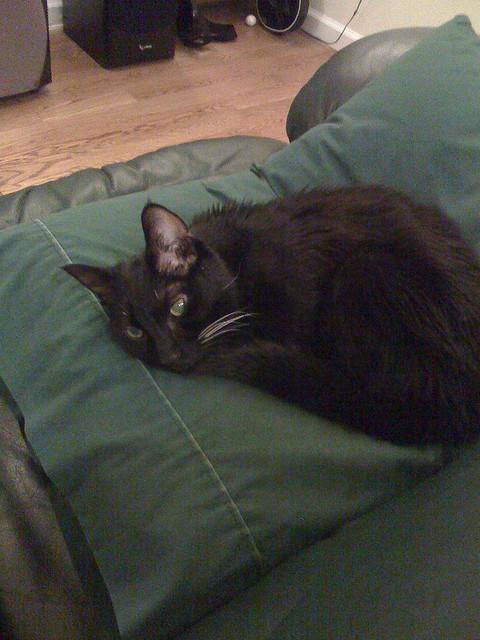Is this cat sleeping?
Answer briefly. No. Does this cat sometimes go outside?
Write a very short answer. Yes. What type of cat is this?
Short answer required. Black. Is this cat siamese?
Short answer required. No. What color is the cat's eyes?
Be succinct. Green. Is the cat sleeping?
Answer briefly. No. What is underneath the cat?
Quick response, please. Pillow. What is the cat laying on?
Give a very brief answer. Pillow. Is the cat cute?
Answer briefly. Yes. Is the cat warm or cold?
Keep it brief. Warm. What color is the black cats face?
Be succinct. Black. Why can't the cat get out the window?
Answer briefly. Sitting. What is the color of the sheet on the bed?
Answer briefly. Green. 